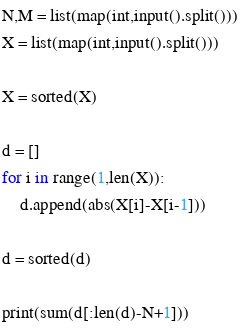Convert code to text. <code><loc_0><loc_0><loc_500><loc_500><_Python_>N,M = list(map(int,input().split()))
X = list(map(int,input().split()))

X = sorted(X)

d = []
for i in range(1,len(X)):
    d.append(abs(X[i]-X[i-1]))

d = sorted(d)

print(sum(d[:len(d)-N+1]))</code> 